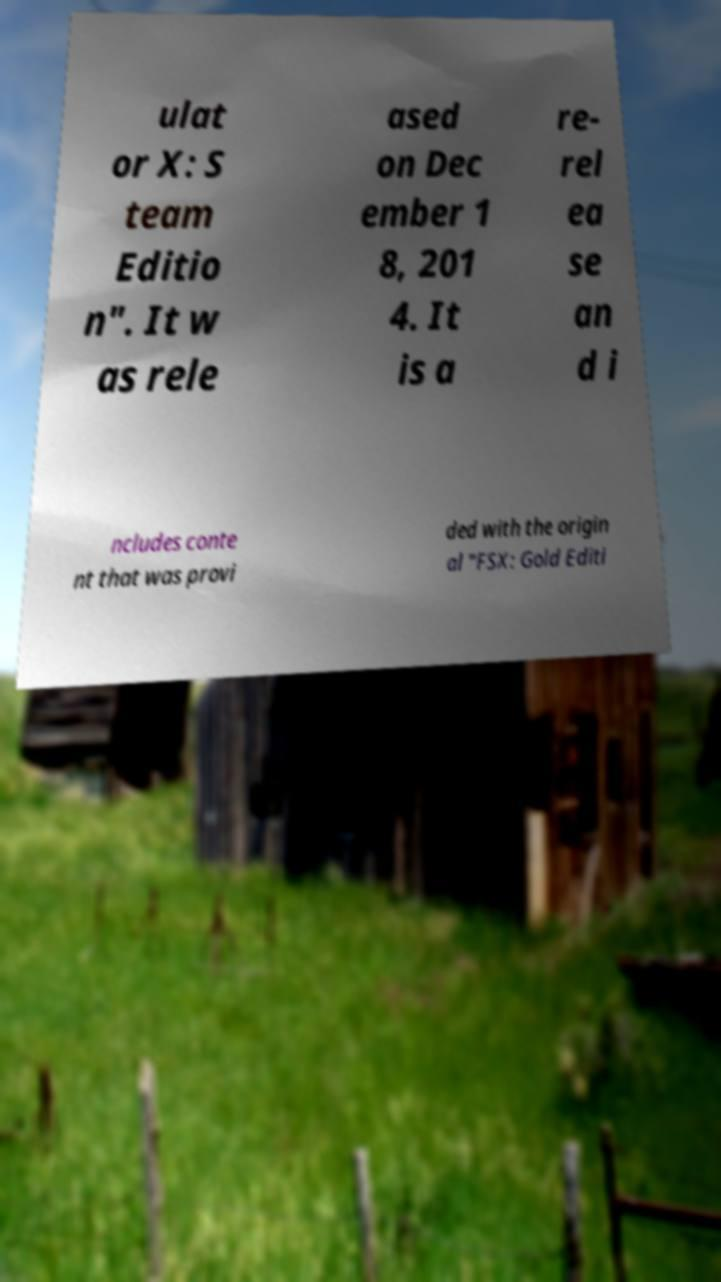Could you assist in decoding the text presented in this image and type it out clearly? ulat or X: S team Editio n". It w as rele ased on Dec ember 1 8, 201 4. It is a re- rel ea se an d i ncludes conte nt that was provi ded with the origin al "FSX: Gold Editi 